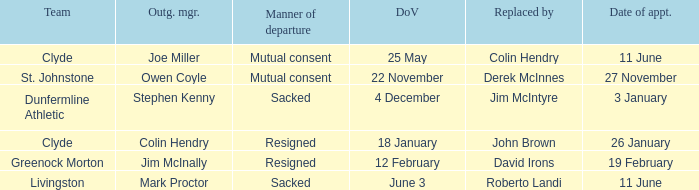Tell me the outgoing manager for livingston Mark Proctor. 